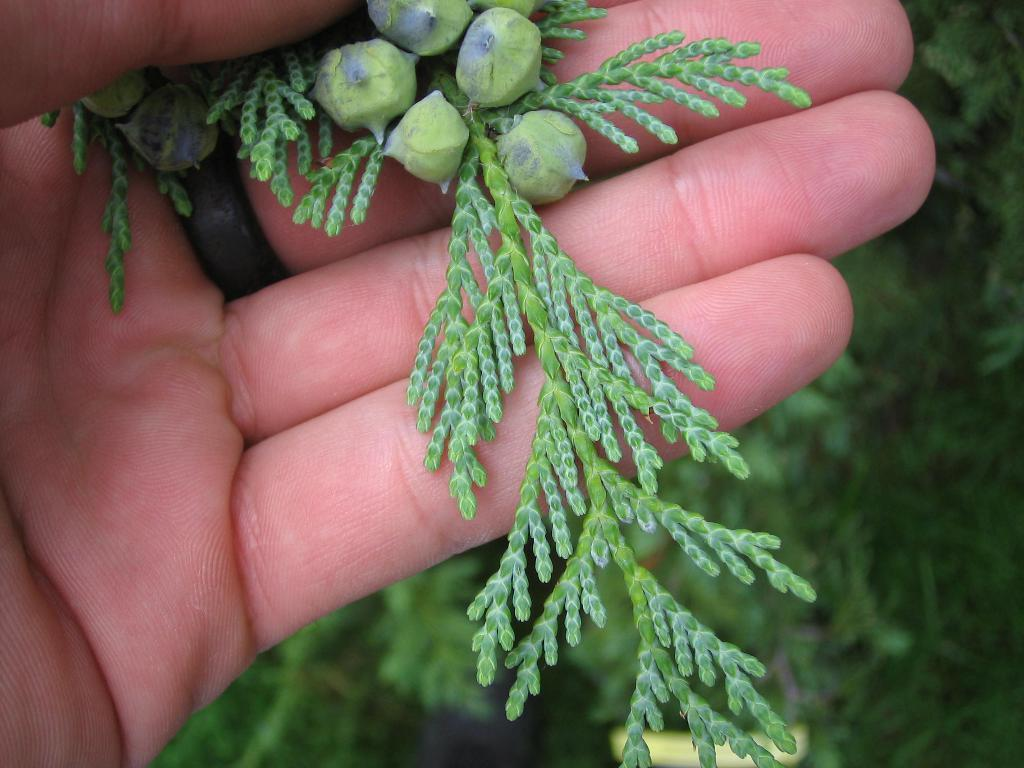What is the hand in the image holding? The hand is holding a plant. What part of the plant can be seen in the image? Green leaves are visible at the bottom of the image. What time of day is it in the image? The time of day cannot be determined from the image, as there are no clues or context provided. 